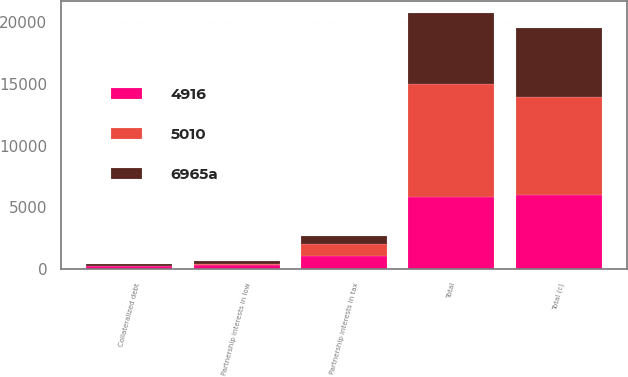Convert chart to OTSL. <chart><loc_0><loc_0><loc_500><loc_500><stacked_bar_chart><ecel><fcel>Partnership interests in tax<fcel>Total (c)<fcel>Collateralized debt<fcel>Partnership interests in low<fcel>Total<nl><fcel>4916<fcel>1095<fcel>6031<fcel>255<fcel>298<fcel>5857<nl><fcel>6965a<fcel>652<fcel>5662<fcel>177<fcel>184<fcel>5691<nl><fcel>5010<fcel>920<fcel>7887<fcel>6<fcel>155<fcel>9180<nl></chart> 